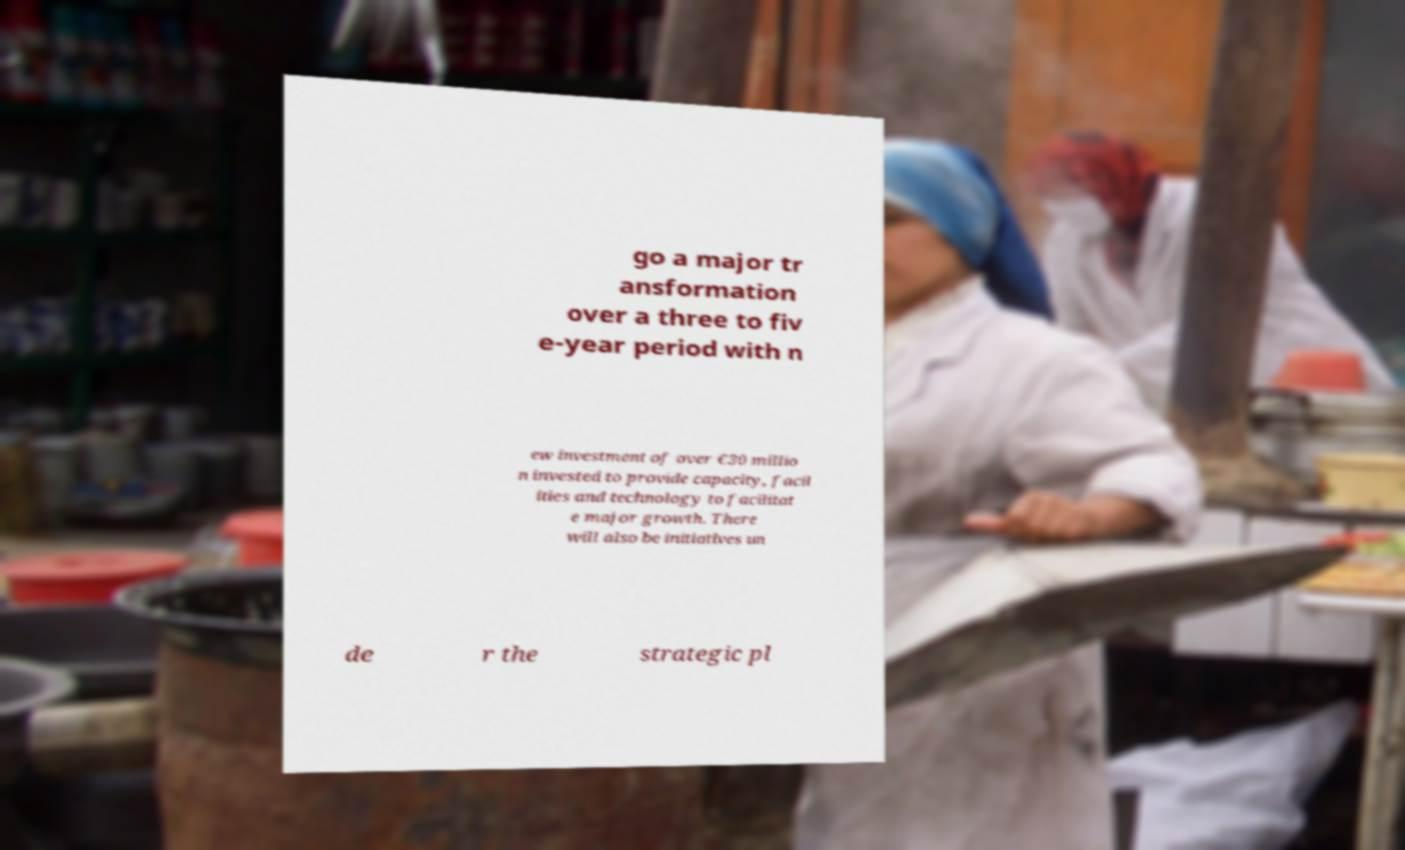Could you extract and type out the text from this image? go a major tr ansformation over a three to fiv e-year period with n ew investment of over €30 millio n invested to provide capacity, facil ities and technology to facilitat e major growth. There will also be initiatives un de r the strategic pl 